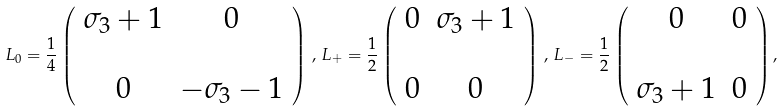<formula> <loc_0><loc_0><loc_500><loc_500>L _ { 0 } = \frac { 1 } { 4 } \left ( \begin{array} { c c } \sigma _ { 3 } + 1 & 0 \\ \\ 0 & - \sigma _ { 3 } - 1 \end{array} \right ) \, , \, L _ { + } = \frac { 1 } { 2 } \left ( \begin{array} { c c } 0 & \sigma _ { 3 } + 1 \\ \\ 0 & 0 \end{array} \right ) \, , \, L _ { - } = \frac { 1 } { 2 } \left ( \begin{array} { c c } 0 & 0 \\ \\ \sigma _ { 3 } + 1 & 0 \end{array} \right ) ,</formula> 